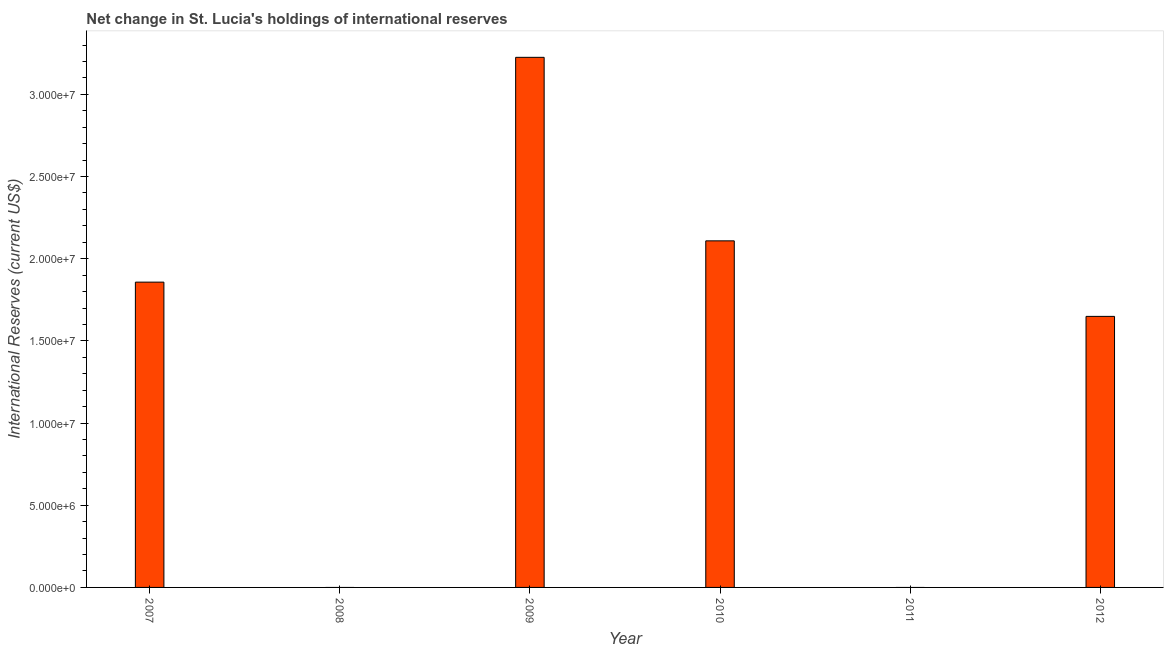Does the graph contain any zero values?
Offer a very short reply. Yes. What is the title of the graph?
Ensure brevity in your answer.  Net change in St. Lucia's holdings of international reserves. What is the label or title of the X-axis?
Offer a very short reply. Year. What is the label or title of the Y-axis?
Ensure brevity in your answer.  International Reserves (current US$). What is the reserves and related items in 2011?
Your answer should be very brief. 0. Across all years, what is the maximum reserves and related items?
Offer a very short reply. 3.23e+07. Across all years, what is the minimum reserves and related items?
Provide a short and direct response. 0. What is the sum of the reserves and related items?
Offer a terse response. 8.84e+07. What is the difference between the reserves and related items in 2009 and 2012?
Give a very brief answer. 1.58e+07. What is the average reserves and related items per year?
Make the answer very short. 1.47e+07. What is the median reserves and related items?
Keep it short and to the point. 1.75e+07. In how many years, is the reserves and related items greater than 6000000 US$?
Your response must be concise. 4. What is the ratio of the reserves and related items in 2007 to that in 2010?
Your answer should be very brief. 0.88. Is the reserves and related items in 2007 less than that in 2012?
Your answer should be compact. No. What is the difference between the highest and the second highest reserves and related items?
Provide a short and direct response. 1.12e+07. What is the difference between the highest and the lowest reserves and related items?
Give a very brief answer. 3.23e+07. How many bars are there?
Offer a very short reply. 4. What is the difference between two consecutive major ticks on the Y-axis?
Offer a very short reply. 5.00e+06. What is the International Reserves (current US$) of 2007?
Your response must be concise. 1.86e+07. What is the International Reserves (current US$) of 2009?
Provide a short and direct response. 3.23e+07. What is the International Reserves (current US$) of 2010?
Give a very brief answer. 2.11e+07. What is the International Reserves (current US$) of 2011?
Give a very brief answer. 0. What is the International Reserves (current US$) of 2012?
Your response must be concise. 1.65e+07. What is the difference between the International Reserves (current US$) in 2007 and 2009?
Make the answer very short. -1.37e+07. What is the difference between the International Reserves (current US$) in 2007 and 2010?
Your response must be concise. -2.51e+06. What is the difference between the International Reserves (current US$) in 2007 and 2012?
Give a very brief answer. 2.08e+06. What is the difference between the International Reserves (current US$) in 2009 and 2010?
Provide a succinct answer. 1.12e+07. What is the difference between the International Reserves (current US$) in 2009 and 2012?
Provide a succinct answer. 1.58e+07. What is the difference between the International Reserves (current US$) in 2010 and 2012?
Offer a very short reply. 4.60e+06. What is the ratio of the International Reserves (current US$) in 2007 to that in 2009?
Provide a short and direct response. 0.58. What is the ratio of the International Reserves (current US$) in 2007 to that in 2010?
Provide a succinct answer. 0.88. What is the ratio of the International Reserves (current US$) in 2007 to that in 2012?
Provide a short and direct response. 1.13. What is the ratio of the International Reserves (current US$) in 2009 to that in 2010?
Offer a very short reply. 1.53. What is the ratio of the International Reserves (current US$) in 2009 to that in 2012?
Offer a very short reply. 1.96. What is the ratio of the International Reserves (current US$) in 2010 to that in 2012?
Ensure brevity in your answer.  1.28. 